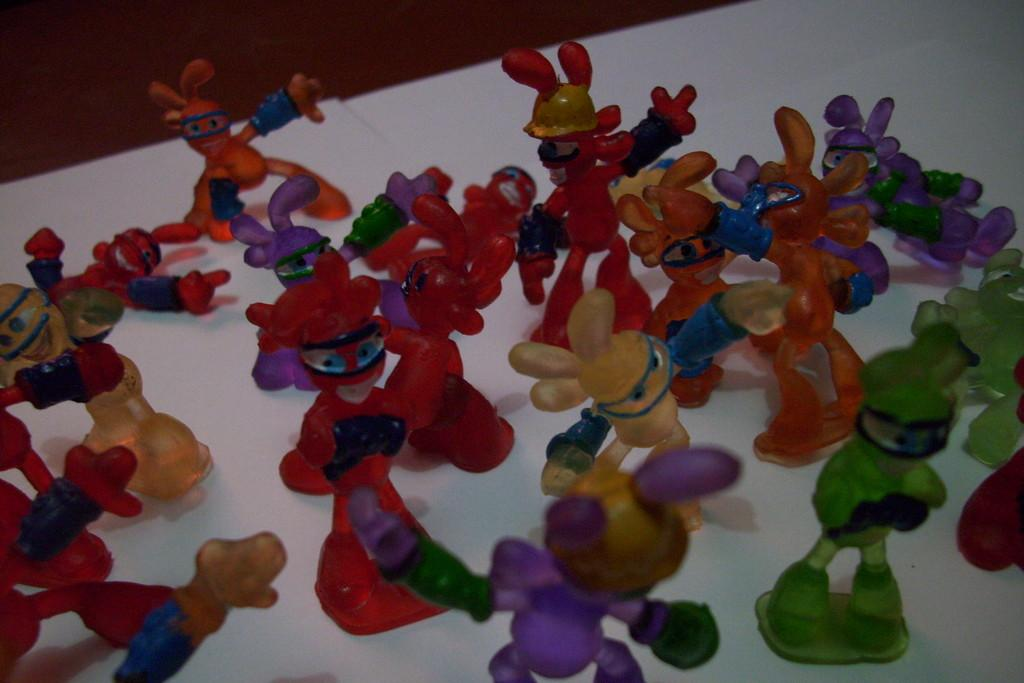What type of furniture is present in the image? There is a table in the image. What is covering the table? There is a white cloth on the table. What objects are placed on the white cloth? There are toys on the white cloth. What type of lunch is being served on the table in the image? There is no lunch being served in the image; it features a table with a white cloth and toys on it. What type of connection is being made between the toys in the image? There is no indication of a connection between the toys in the image; they are simply placed on the white cloth. 